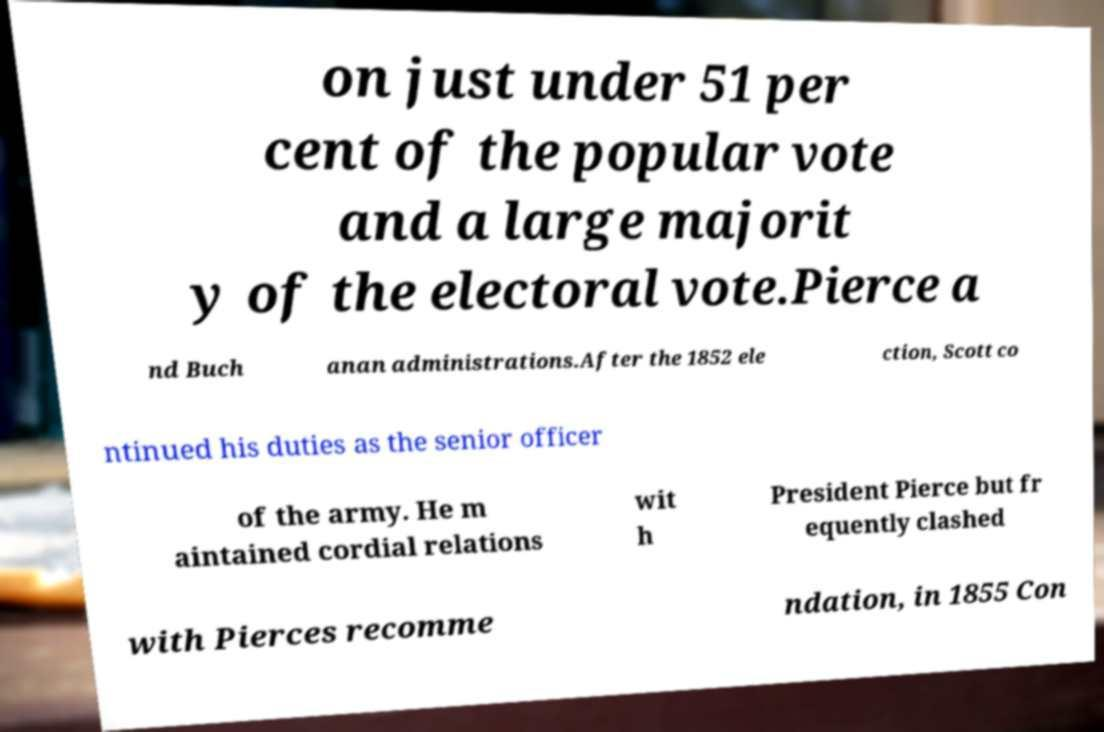Please identify and transcribe the text found in this image. on just under 51 per cent of the popular vote and a large majorit y of the electoral vote.Pierce a nd Buch anan administrations.After the 1852 ele ction, Scott co ntinued his duties as the senior officer of the army. He m aintained cordial relations wit h President Pierce but fr equently clashed with Pierces recomme ndation, in 1855 Con 